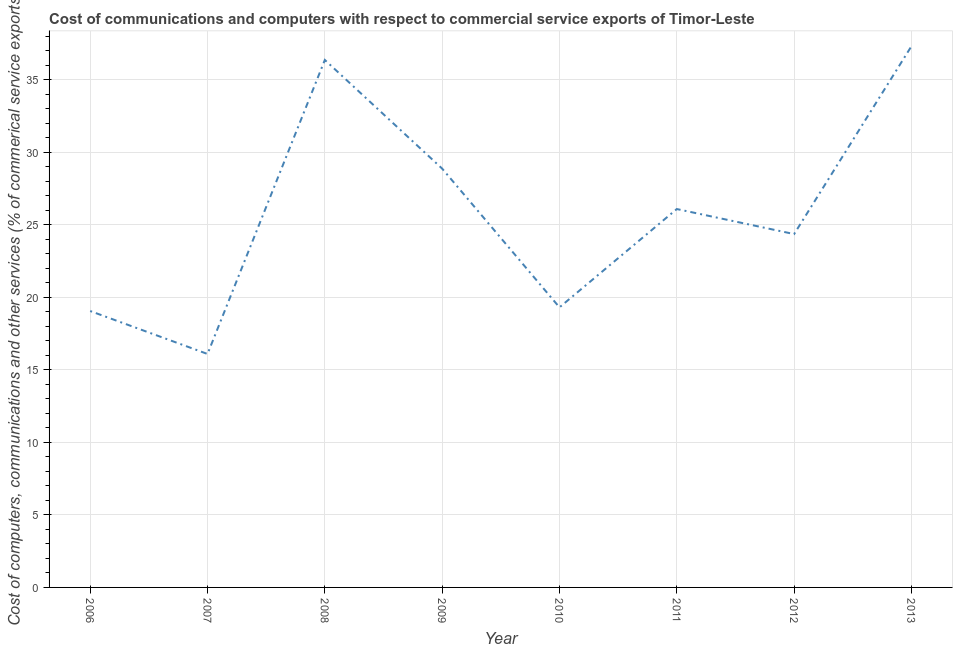What is the  computer and other services in 2012?
Offer a terse response. 24.36. Across all years, what is the maximum  computer and other services?
Provide a succinct answer. 37.32. Across all years, what is the minimum  computer and other services?
Provide a short and direct response. 16.1. In which year was the cost of communications maximum?
Provide a short and direct response. 2013. In which year was the cost of communications minimum?
Your answer should be very brief. 2007. What is the sum of the cost of communications?
Offer a very short reply. 207.48. What is the difference between the  computer and other services in 2006 and 2012?
Offer a very short reply. -5.31. What is the average cost of communications per year?
Keep it short and to the point. 25.94. What is the median cost of communications?
Offer a terse response. 25.23. Do a majority of the years between 2010 and 2008 (inclusive) have cost of communications greater than 10 %?
Your answer should be compact. No. What is the ratio of the cost of communications in 2008 to that in 2011?
Ensure brevity in your answer.  1.39. Is the cost of communications in 2010 less than that in 2012?
Provide a short and direct response. Yes. Is the difference between the  computer and other services in 2009 and 2013 greater than the difference between any two years?
Provide a succinct answer. No. What is the difference between the highest and the second highest cost of communications?
Make the answer very short. 0.95. What is the difference between the highest and the lowest  computer and other services?
Offer a terse response. 21.22. In how many years, is the cost of communications greater than the average cost of communications taken over all years?
Offer a terse response. 4. How many lines are there?
Your answer should be compact. 1. How many years are there in the graph?
Ensure brevity in your answer.  8. Are the values on the major ticks of Y-axis written in scientific E-notation?
Your answer should be compact. No. Does the graph contain grids?
Offer a very short reply. Yes. What is the title of the graph?
Provide a short and direct response. Cost of communications and computers with respect to commercial service exports of Timor-Leste. What is the label or title of the X-axis?
Give a very brief answer. Year. What is the label or title of the Y-axis?
Give a very brief answer. Cost of computers, communications and other services (% of commerical service exports). What is the Cost of computers, communications and other services (% of commerical service exports) in 2006?
Make the answer very short. 19.06. What is the Cost of computers, communications and other services (% of commerical service exports) in 2007?
Ensure brevity in your answer.  16.1. What is the Cost of computers, communications and other services (% of commerical service exports) of 2008?
Make the answer very short. 36.37. What is the Cost of computers, communications and other services (% of commerical service exports) of 2009?
Provide a short and direct response. 28.88. What is the Cost of computers, communications and other services (% of commerical service exports) in 2010?
Ensure brevity in your answer.  19.31. What is the Cost of computers, communications and other services (% of commerical service exports) of 2011?
Offer a very short reply. 26.09. What is the Cost of computers, communications and other services (% of commerical service exports) in 2012?
Offer a very short reply. 24.36. What is the Cost of computers, communications and other services (% of commerical service exports) of 2013?
Ensure brevity in your answer.  37.32. What is the difference between the Cost of computers, communications and other services (% of commerical service exports) in 2006 and 2007?
Offer a very short reply. 2.96. What is the difference between the Cost of computers, communications and other services (% of commerical service exports) in 2006 and 2008?
Offer a very short reply. -17.31. What is the difference between the Cost of computers, communications and other services (% of commerical service exports) in 2006 and 2009?
Your answer should be very brief. -9.82. What is the difference between the Cost of computers, communications and other services (% of commerical service exports) in 2006 and 2010?
Your answer should be compact. -0.25. What is the difference between the Cost of computers, communications and other services (% of commerical service exports) in 2006 and 2011?
Offer a terse response. -7.03. What is the difference between the Cost of computers, communications and other services (% of commerical service exports) in 2006 and 2012?
Your answer should be compact. -5.31. What is the difference between the Cost of computers, communications and other services (% of commerical service exports) in 2006 and 2013?
Your answer should be compact. -18.26. What is the difference between the Cost of computers, communications and other services (% of commerical service exports) in 2007 and 2008?
Your answer should be compact. -20.27. What is the difference between the Cost of computers, communications and other services (% of commerical service exports) in 2007 and 2009?
Make the answer very short. -12.78. What is the difference between the Cost of computers, communications and other services (% of commerical service exports) in 2007 and 2010?
Your answer should be compact. -3.22. What is the difference between the Cost of computers, communications and other services (% of commerical service exports) in 2007 and 2011?
Keep it short and to the point. -9.99. What is the difference between the Cost of computers, communications and other services (% of commerical service exports) in 2007 and 2012?
Provide a short and direct response. -8.27. What is the difference between the Cost of computers, communications and other services (% of commerical service exports) in 2007 and 2013?
Ensure brevity in your answer.  -21.22. What is the difference between the Cost of computers, communications and other services (% of commerical service exports) in 2008 and 2009?
Your response must be concise. 7.49. What is the difference between the Cost of computers, communications and other services (% of commerical service exports) in 2008 and 2010?
Give a very brief answer. 17.06. What is the difference between the Cost of computers, communications and other services (% of commerical service exports) in 2008 and 2011?
Make the answer very short. 10.28. What is the difference between the Cost of computers, communications and other services (% of commerical service exports) in 2008 and 2012?
Provide a succinct answer. 12.01. What is the difference between the Cost of computers, communications and other services (% of commerical service exports) in 2008 and 2013?
Keep it short and to the point. -0.95. What is the difference between the Cost of computers, communications and other services (% of commerical service exports) in 2009 and 2010?
Make the answer very short. 9.57. What is the difference between the Cost of computers, communications and other services (% of commerical service exports) in 2009 and 2011?
Your response must be concise. 2.79. What is the difference between the Cost of computers, communications and other services (% of commerical service exports) in 2009 and 2012?
Provide a short and direct response. 4.51. What is the difference between the Cost of computers, communications and other services (% of commerical service exports) in 2009 and 2013?
Offer a very short reply. -8.44. What is the difference between the Cost of computers, communications and other services (% of commerical service exports) in 2010 and 2011?
Provide a succinct answer. -6.78. What is the difference between the Cost of computers, communications and other services (% of commerical service exports) in 2010 and 2012?
Your answer should be very brief. -5.05. What is the difference between the Cost of computers, communications and other services (% of commerical service exports) in 2010 and 2013?
Make the answer very short. -18.01. What is the difference between the Cost of computers, communications and other services (% of commerical service exports) in 2011 and 2012?
Make the answer very short. 1.73. What is the difference between the Cost of computers, communications and other services (% of commerical service exports) in 2011 and 2013?
Offer a terse response. -11.23. What is the difference between the Cost of computers, communications and other services (% of commerical service exports) in 2012 and 2013?
Your answer should be very brief. -12.95. What is the ratio of the Cost of computers, communications and other services (% of commerical service exports) in 2006 to that in 2007?
Offer a very short reply. 1.18. What is the ratio of the Cost of computers, communications and other services (% of commerical service exports) in 2006 to that in 2008?
Ensure brevity in your answer.  0.52. What is the ratio of the Cost of computers, communications and other services (% of commerical service exports) in 2006 to that in 2009?
Offer a very short reply. 0.66. What is the ratio of the Cost of computers, communications and other services (% of commerical service exports) in 2006 to that in 2010?
Offer a very short reply. 0.99. What is the ratio of the Cost of computers, communications and other services (% of commerical service exports) in 2006 to that in 2011?
Provide a succinct answer. 0.73. What is the ratio of the Cost of computers, communications and other services (% of commerical service exports) in 2006 to that in 2012?
Provide a short and direct response. 0.78. What is the ratio of the Cost of computers, communications and other services (% of commerical service exports) in 2006 to that in 2013?
Offer a terse response. 0.51. What is the ratio of the Cost of computers, communications and other services (% of commerical service exports) in 2007 to that in 2008?
Provide a short and direct response. 0.44. What is the ratio of the Cost of computers, communications and other services (% of commerical service exports) in 2007 to that in 2009?
Your answer should be compact. 0.56. What is the ratio of the Cost of computers, communications and other services (% of commerical service exports) in 2007 to that in 2010?
Offer a terse response. 0.83. What is the ratio of the Cost of computers, communications and other services (% of commerical service exports) in 2007 to that in 2011?
Your answer should be compact. 0.62. What is the ratio of the Cost of computers, communications and other services (% of commerical service exports) in 2007 to that in 2012?
Offer a very short reply. 0.66. What is the ratio of the Cost of computers, communications and other services (% of commerical service exports) in 2007 to that in 2013?
Provide a short and direct response. 0.43. What is the ratio of the Cost of computers, communications and other services (% of commerical service exports) in 2008 to that in 2009?
Offer a terse response. 1.26. What is the ratio of the Cost of computers, communications and other services (% of commerical service exports) in 2008 to that in 2010?
Your answer should be compact. 1.88. What is the ratio of the Cost of computers, communications and other services (% of commerical service exports) in 2008 to that in 2011?
Provide a succinct answer. 1.39. What is the ratio of the Cost of computers, communications and other services (% of commerical service exports) in 2008 to that in 2012?
Offer a terse response. 1.49. What is the ratio of the Cost of computers, communications and other services (% of commerical service exports) in 2009 to that in 2010?
Keep it short and to the point. 1.5. What is the ratio of the Cost of computers, communications and other services (% of commerical service exports) in 2009 to that in 2011?
Make the answer very short. 1.11. What is the ratio of the Cost of computers, communications and other services (% of commerical service exports) in 2009 to that in 2012?
Provide a short and direct response. 1.19. What is the ratio of the Cost of computers, communications and other services (% of commerical service exports) in 2009 to that in 2013?
Offer a very short reply. 0.77. What is the ratio of the Cost of computers, communications and other services (% of commerical service exports) in 2010 to that in 2011?
Ensure brevity in your answer.  0.74. What is the ratio of the Cost of computers, communications and other services (% of commerical service exports) in 2010 to that in 2012?
Your response must be concise. 0.79. What is the ratio of the Cost of computers, communications and other services (% of commerical service exports) in 2010 to that in 2013?
Provide a short and direct response. 0.52. What is the ratio of the Cost of computers, communications and other services (% of commerical service exports) in 2011 to that in 2012?
Your answer should be compact. 1.07. What is the ratio of the Cost of computers, communications and other services (% of commerical service exports) in 2011 to that in 2013?
Provide a short and direct response. 0.7. What is the ratio of the Cost of computers, communications and other services (% of commerical service exports) in 2012 to that in 2013?
Your answer should be compact. 0.65. 